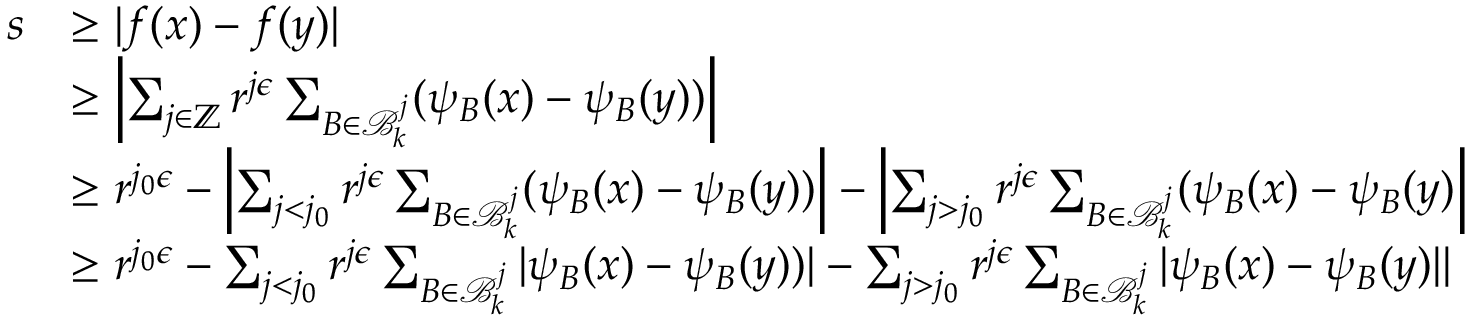Convert formula to latex. <formula><loc_0><loc_0><loc_500><loc_500>\begin{array} { r l } { s } & { \geq | f ( x ) - f ( y ) | } \\ & { \geq \left | \sum _ { j \in \mathbb { Z } } r ^ { j \epsilon } \sum _ { B \in \mathcal { B } _ { k } ^ { j } } ( \psi _ { B } ( x ) - \psi _ { B } ( y ) ) \right | } \\ & { \geq r ^ { j _ { 0 } \epsilon } - \left | \sum _ { j < j _ { 0 } } r ^ { j \epsilon } \sum _ { B \in \mathcal { B } _ { k } ^ { j } } ( \psi _ { B } ( x ) - \psi _ { B } ( y ) ) \right | - \left | \sum _ { j > j _ { 0 } } r ^ { j \epsilon } \sum _ { B \in \mathcal { B } _ { k } ^ { j } } ( \psi _ { B } ( x ) - \psi _ { B } ( y ) \right | } \\ & { \geq r ^ { j _ { 0 } \epsilon } - \sum _ { j < j _ { 0 } } r ^ { j \epsilon } \sum _ { B \in \mathcal { B } _ { k } ^ { j } } | \psi _ { B } ( x ) - \psi _ { B } ( y ) ) | - \sum _ { j > j _ { 0 } } r ^ { j \epsilon } \sum _ { B \in \mathcal { B } _ { k } ^ { j } } | \psi _ { B } ( x ) - \psi _ { B } ( y ) | | } \end{array}</formula> 